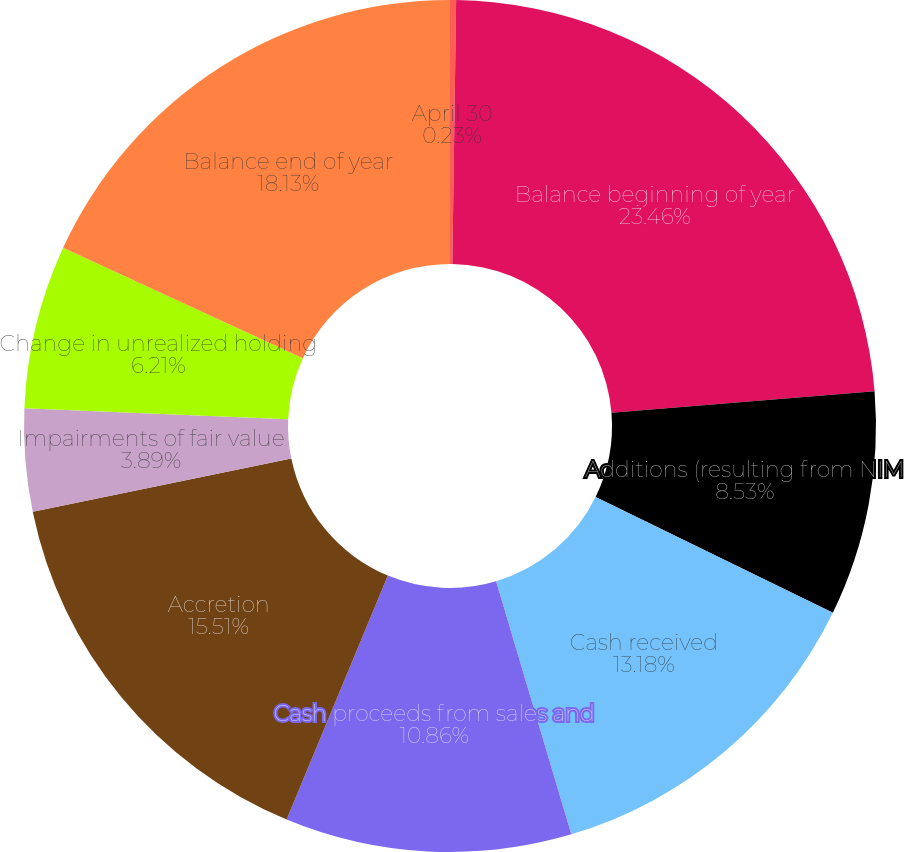Convert chart to OTSL. <chart><loc_0><loc_0><loc_500><loc_500><pie_chart><fcel>April 30<fcel>Balance beginning of year<fcel>Additions (resulting from NIM<fcel>Cash received<fcel>Cash proceeds from sales and<fcel>Accretion<fcel>Impairments of fair value<fcel>Change in unrealized holding<fcel>Balance end of year<nl><fcel>0.23%<fcel>23.47%<fcel>8.53%<fcel>13.18%<fcel>10.86%<fcel>15.51%<fcel>3.89%<fcel>6.21%<fcel>18.13%<nl></chart> 